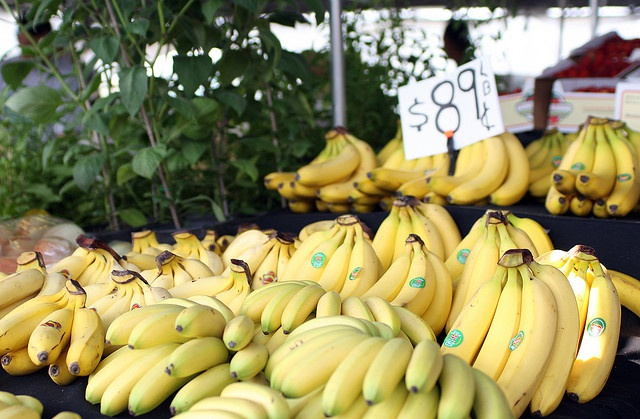Describe the objects in this image and their specific colors. I can see banana in gray, khaki, and tan tones, banana in gray, khaki, and tan tones, banana in gray, khaki, and olive tones, banana in gray, tan, black, and olive tones, and banana in gray, khaki, tan, and black tones in this image. 